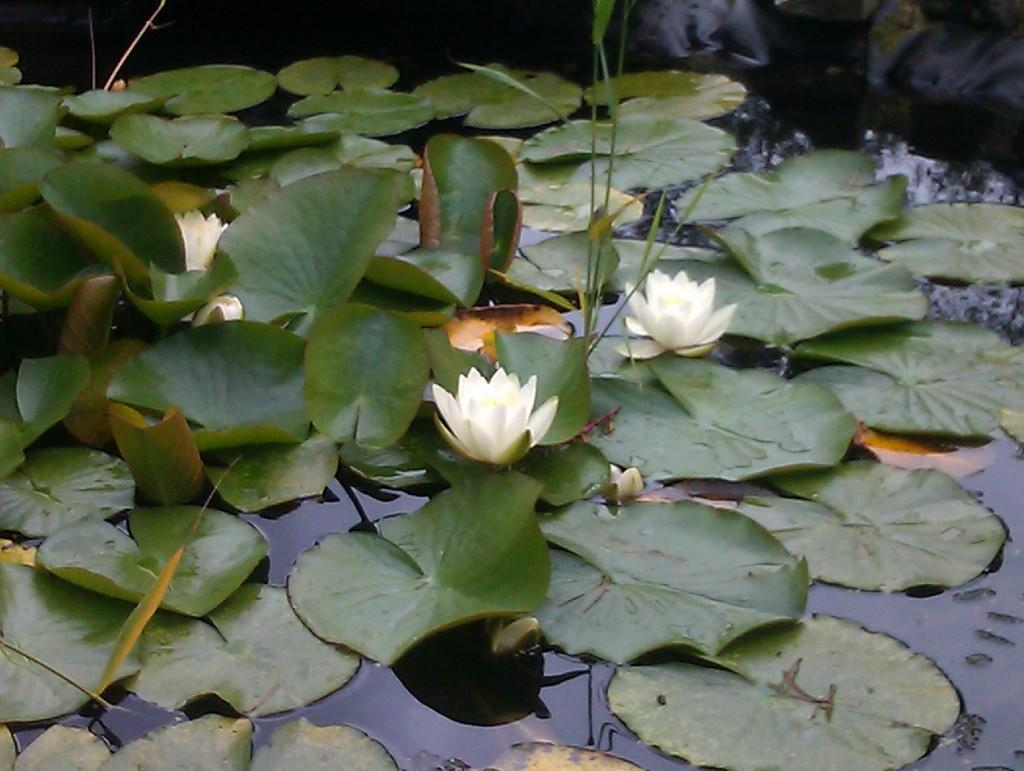What type of flowers are on the water in the image? There are lotus flowers on the water in the image. What else can be seen in the image besides the lotus flowers? There are leaves visible in the image. What type of drink is being served with a fork in the image? There is no drink or fork present in the image; it features lotus flowers on the water and leaves. 